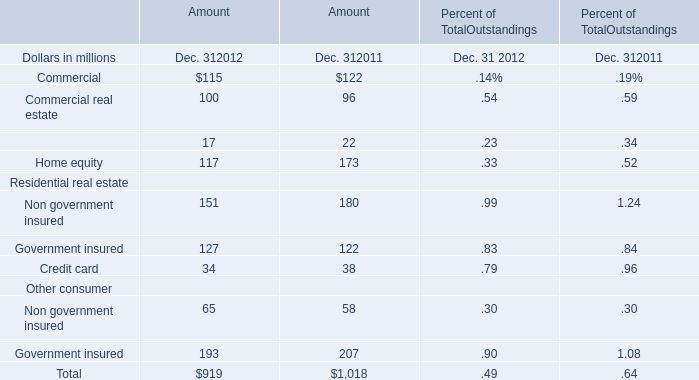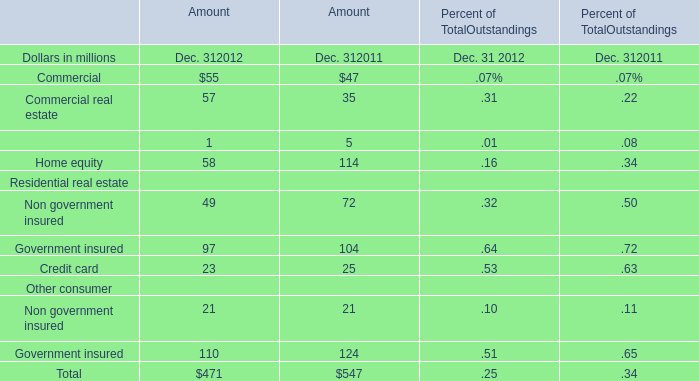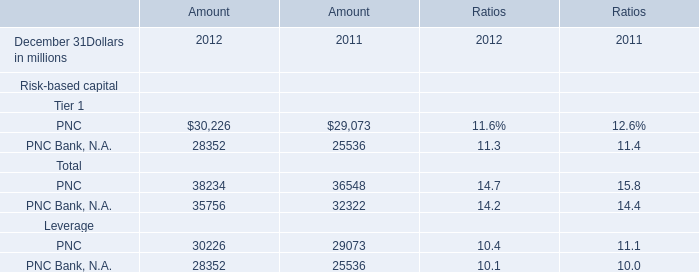What do all Residential real estate sum up without those Residential real estate smaller than 50, in 2012? (in million) 
Computations: (49 + 23)
Answer: 72.0. 